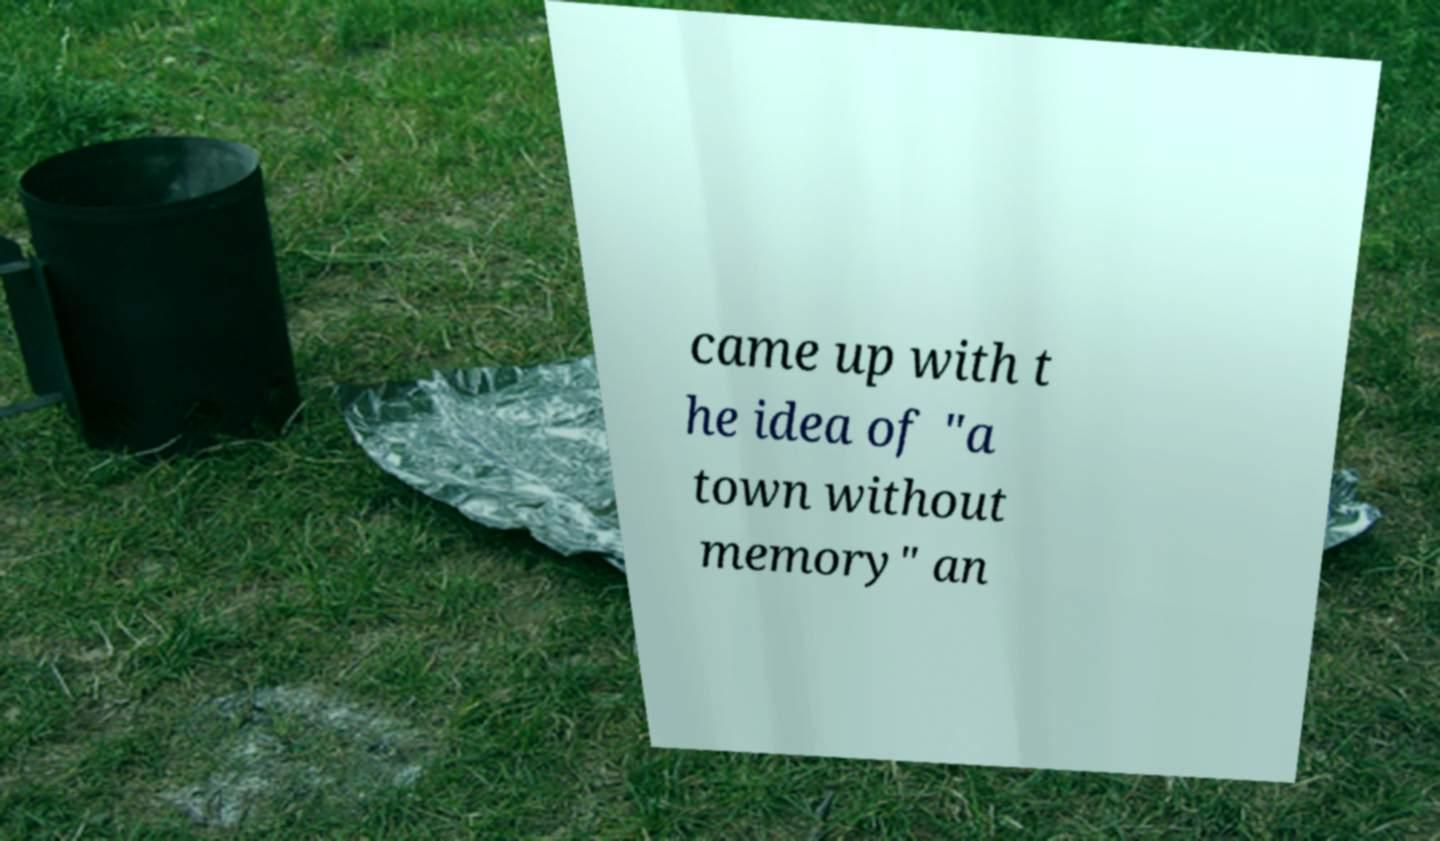Can you accurately transcribe the text from the provided image for me? came up with t he idea of "a town without memory" an 